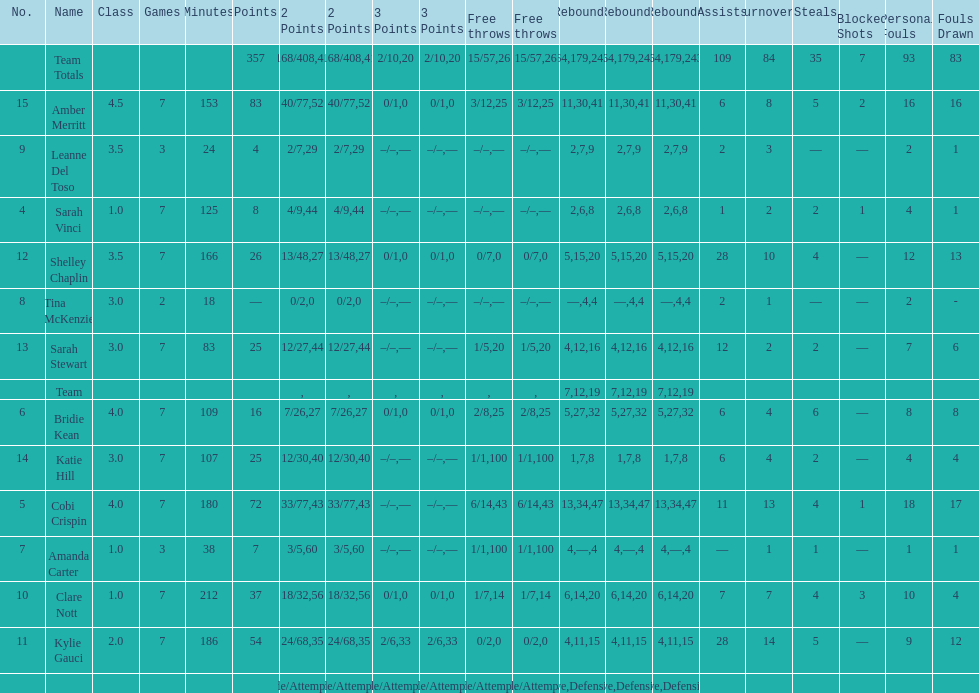Next to merritt, who was the top scorer? Cobi Crispin. 